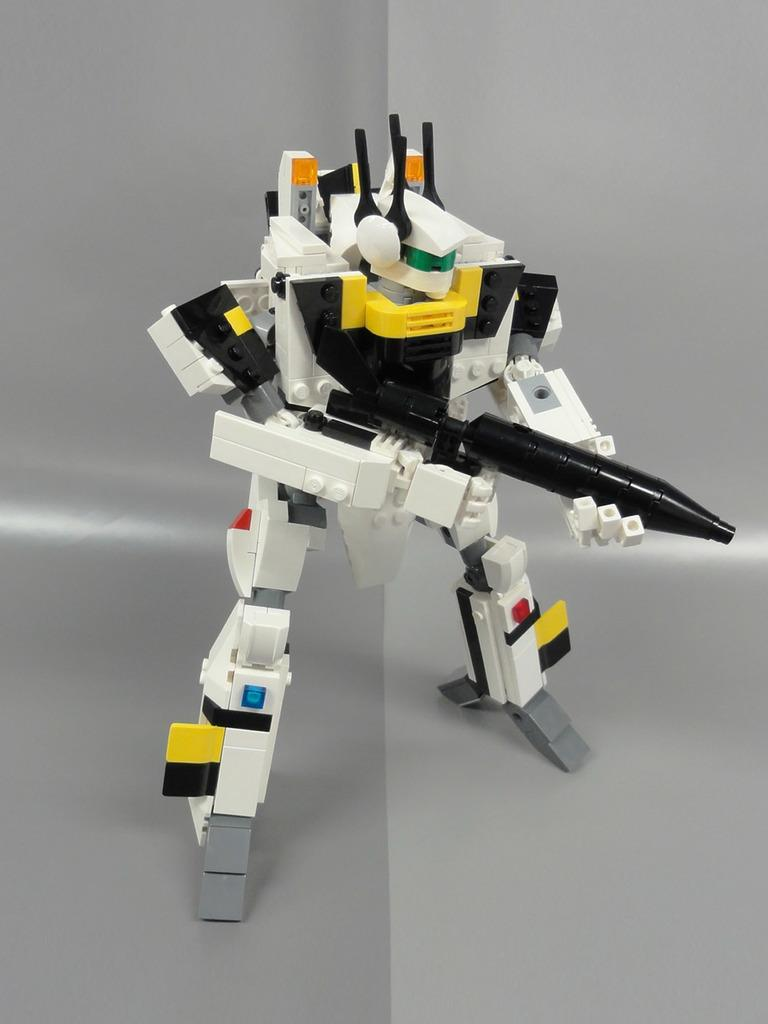What is the main subject of the image? The main subject of the image is a small robot. What type of plantation can be seen in the background of the image? There is no plantation present in the image; it features a small robot as the main subject. 